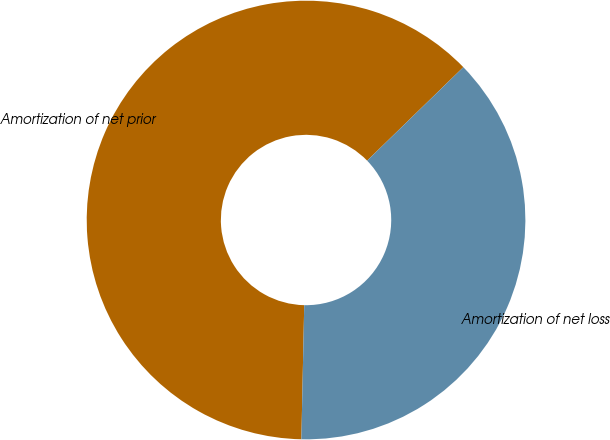Convert chart to OTSL. <chart><loc_0><loc_0><loc_500><loc_500><pie_chart><fcel>Amortization of net prior<fcel>Amortization of net loss<nl><fcel>62.39%<fcel>37.61%<nl></chart> 